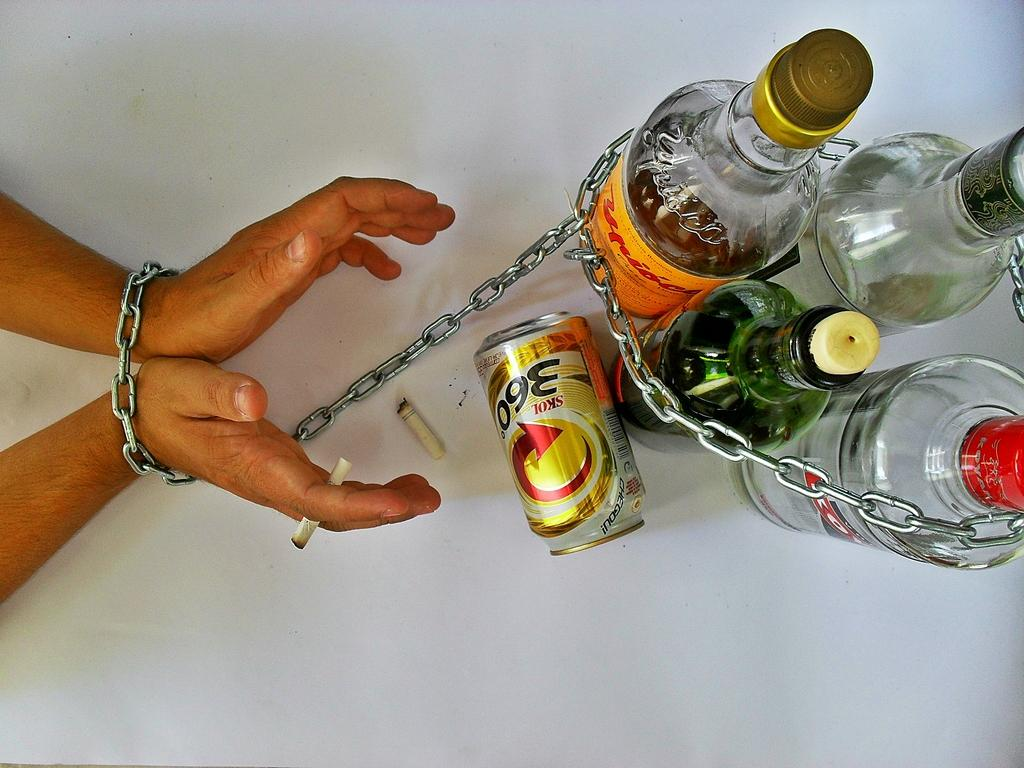What can be seen in the image related to containers? There are different types of bottles in the image. What other object can be seen in the image? There is a chain in the image. What is the nature of the smoke in the image? Smoke is visible in the image. What body part is present in the image? Hands are present in the image. What does the self say to the uncle in the image? There is no self or uncle present in the image, so there is no conversation between them. Are there any fairies visible in the image? There are no fairies present in the image. 